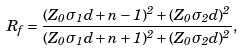<formula> <loc_0><loc_0><loc_500><loc_500>R _ { f } = \frac { ( Z _ { 0 } \sigma _ { 1 } d + n - 1 ) ^ { 2 } + ( Z _ { 0 } \sigma _ { 2 } d ) ^ { 2 } } { ( Z _ { 0 } \sigma _ { 1 } d + n + 1 ) ^ { 2 } + ( Z _ { 0 } \sigma _ { 2 } d ) ^ { 2 } } ,</formula> 